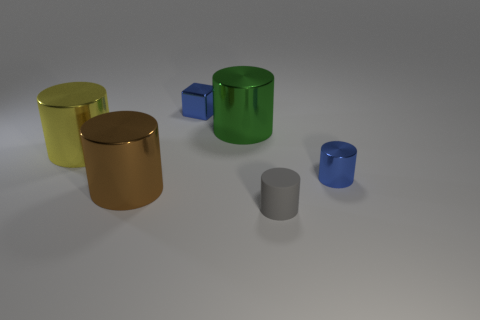Subtract all tiny gray matte cylinders. How many cylinders are left? 4 Subtract all brown cylinders. How many cylinders are left? 4 Subtract all cyan cylinders. Subtract all blue spheres. How many cylinders are left? 5 Add 3 yellow metal cylinders. How many objects exist? 9 Subtract all cubes. How many objects are left? 5 Subtract 1 brown cylinders. How many objects are left? 5 Subtract all small shiny objects. Subtract all small metallic cylinders. How many objects are left? 3 Add 1 small blue metallic cubes. How many small blue metallic cubes are left? 2 Add 3 large green matte blocks. How many large green matte blocks exist? 3 